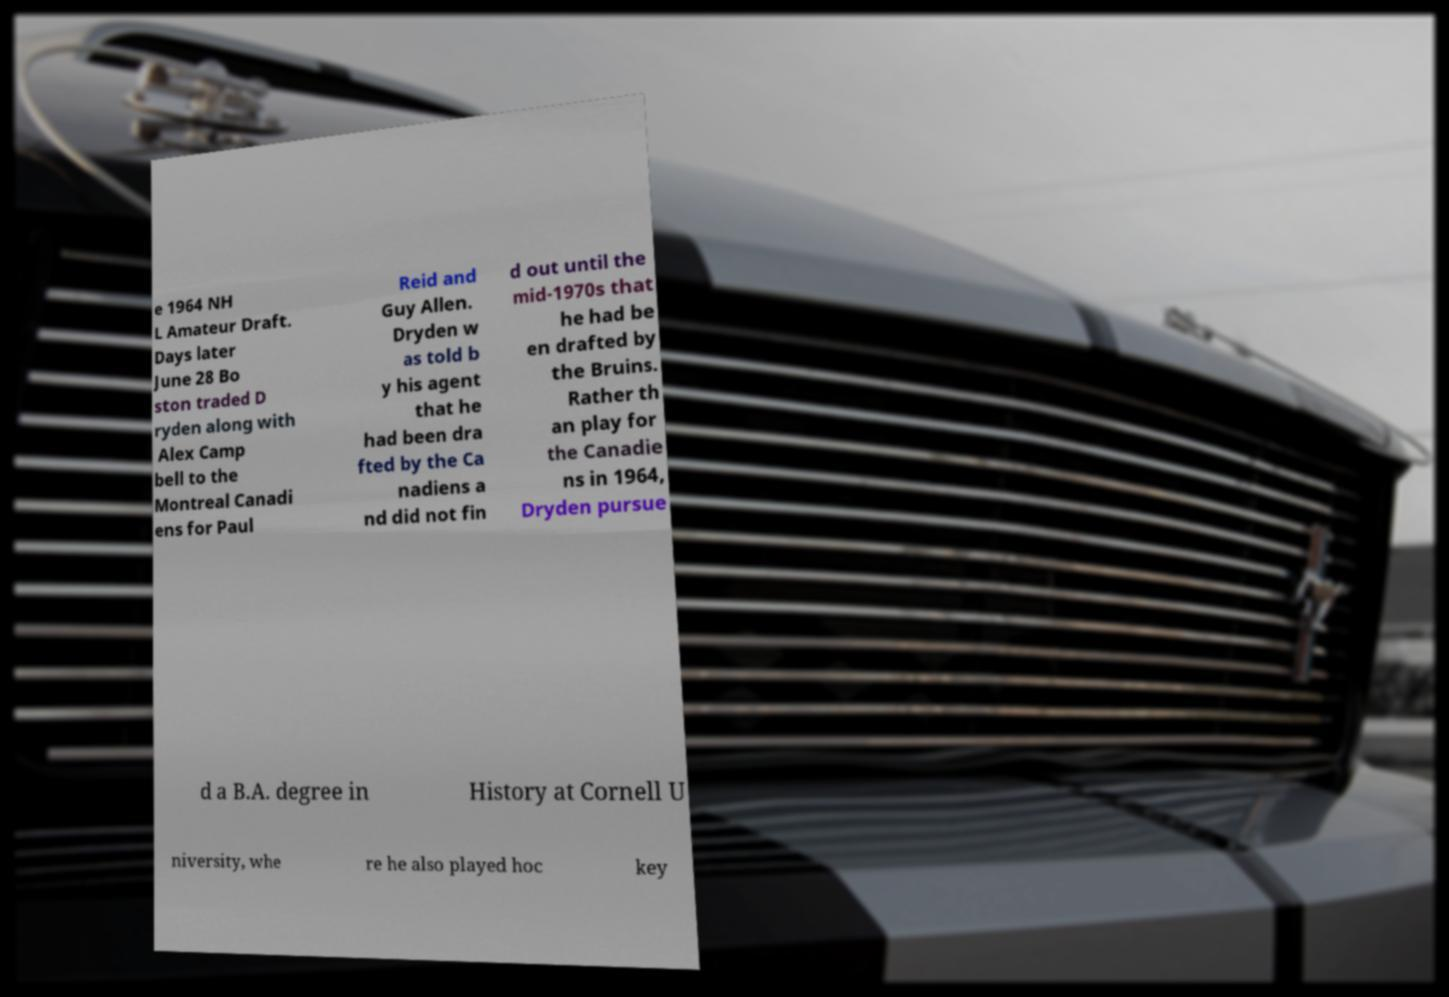Please read and relay the text visible in this image. What does it say? e 1964 NH L Amateur Draft. Days later June 28 Bo ston traded D ryden along with Alex Camp bell to the Montreal Canadi ens for Paul Reid and Guy Allen. Dryden w as told b y his agent that he had been dra fted by the Ca nadiens a nd did not fin d out until the mid-1970s that he had be en drafted by the Bruins. Rather th an play for the Canadie ns in 1964, Dryden pursue d a B.A. degree in History at Cornell U niversity, whe re he also played hoc key 